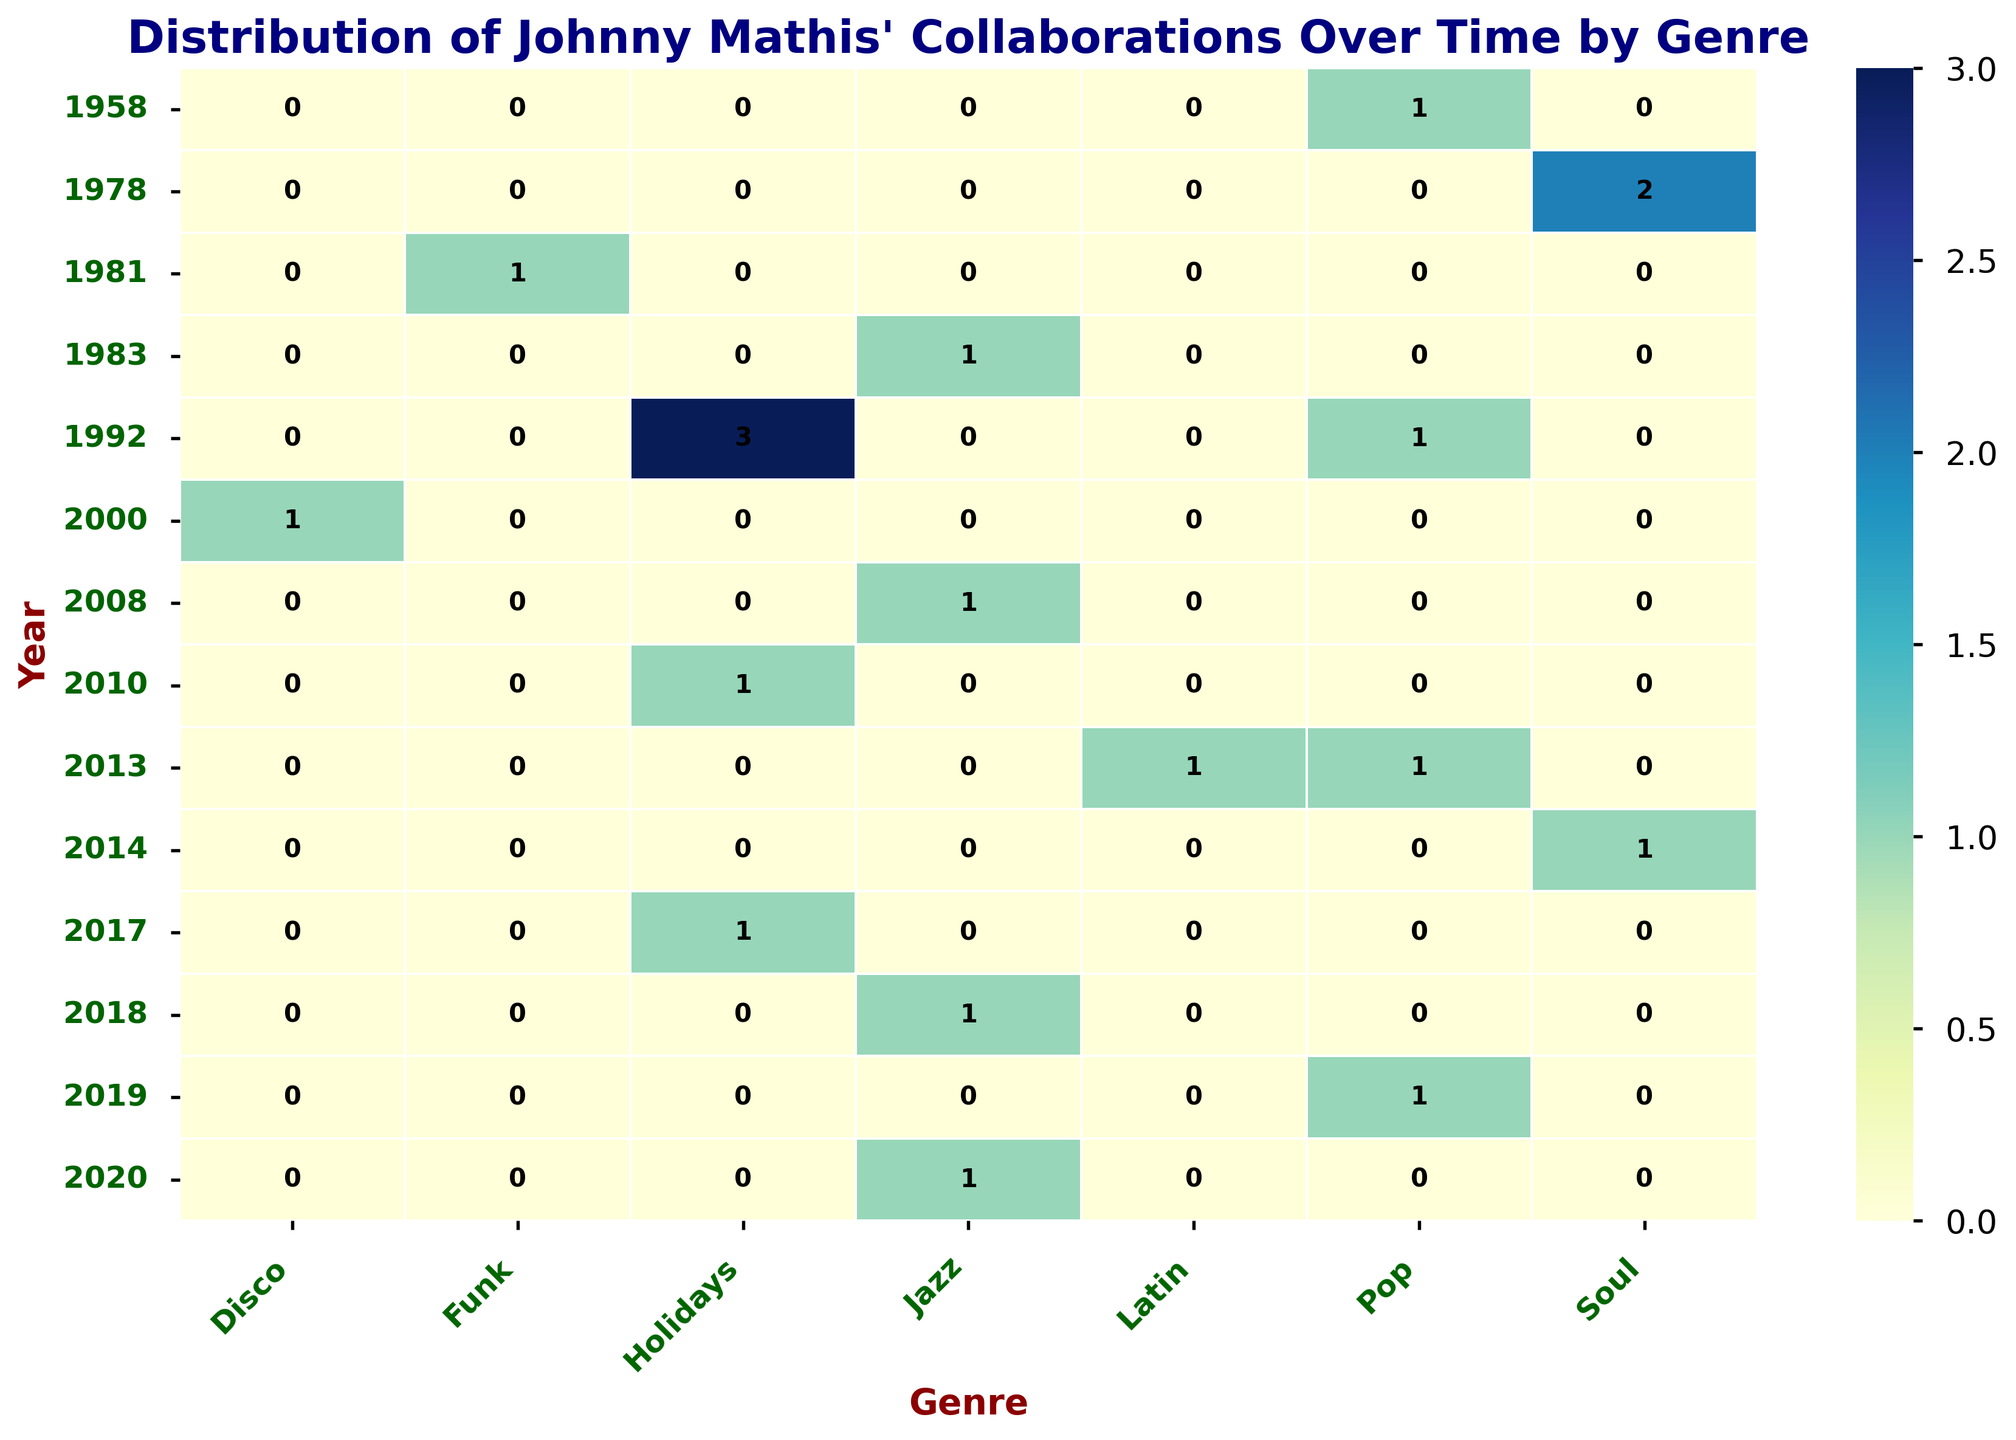What is the most frequent genre of Johnny Mathis' collaborations from 2010 to 2020? Inspect the heatmap from the years 2010 to 2020 and count the number of times each genre appears. The genre with the highest count is the most frequent.
Answer: Jazz Which collaborator has the highest number of collaborations in 1992? Look at the year 1992 on the heatmap and check which genre has the highest count. Then, match the genre to the collaborator for that year.
Answer: Johnny Cash How many total collaborations did Johnny Mathis have in the year 2013? Examine the 2013 row in the heatmap and sum the counts for all genres in that year.
Answer: 2 Which genre did Johnny Mathis collaborate in more frequently, Pop or Jazz? Sum the values for the "Pop" and "Jazz" columns in the heatmap. Compare the two sums.
Answer: Pop In which year did Johnny Mathis have the greatest number of collaborations in the Holidays genre? Look at the "Holidays" column and identify the year with the highest count.
Answer: 1992 Which genre appears in the fewest years on the heatmap? Count the occurrences of each genre across all years and find the genre with the fewest unique years.
Answer: Funk How many genres are represented in the collaborations from 2018? Inspect the heatmap for the year 2018 and count the number of genres with a non-zero value.
Answer: 1 What is the difference between the number of collaborations in the Jazz genre in 2010 and the number in 2020? Check the counts in the "Jazz" column for the years 2010 and 2020, then subtract the 2010 value from the 2020 value.
Answer: 1 How many years feature collaborations across three or more genres? For each year, count the number of genres with non-zero values. Identify the years where this count is three or more.
Answer: 1 